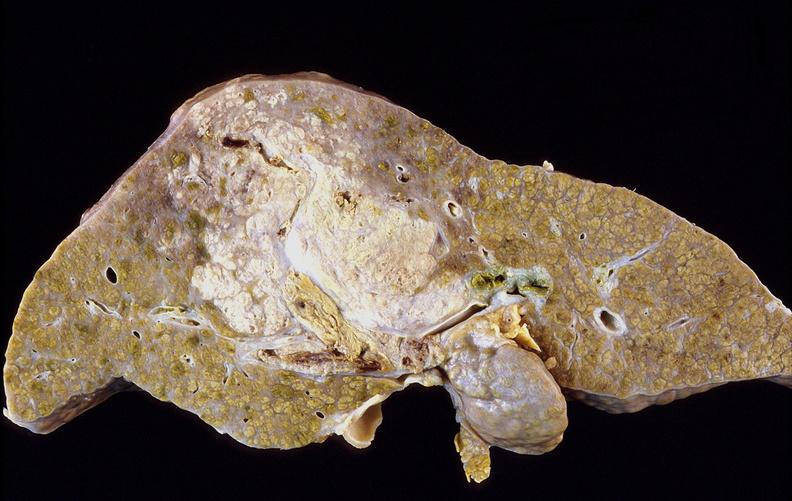s liver present?
Answer the question using a single word or phrase. Yes 